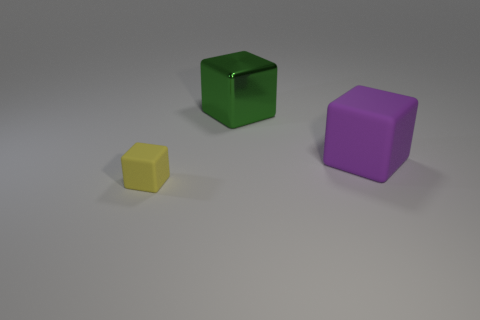What number of big objects are either green cubes or rubber things?
Your response must be concise. 2. There is a rubber object that is on the right side of the rubber block left of the large green metal thing; what color is it?
Keep it short and to the point. Purple. Does the green thing have the same material as the thing in front of the large rubber cube?
Provide a short and direct response. No. There is a big object left of the purple rubber block; what is it made of?
Your answer should be very brief. Metal. Are there an equal number of yellow cubes to the right of the yellow rubber object and big gray things?
Provide a succinct answer. Yes. Is there anything else that has the same size as the yellow rubber object?
Your response must be concise. No. What is the big object that is on the left side of the large cube in front of the shiny cube made of?
Make the answer very short. Metal. The other rubber thing that is the same shape as the yellow rubber thing is what size?
Ensure brevity in your answer.  Large. Is the number of big purple blocks that are behind the big purple block less than the number of brown rubber things?
Offer a terse response. No. There is a thing that is to the right of the green object; what is its size?
Make the answer very short. Large. 